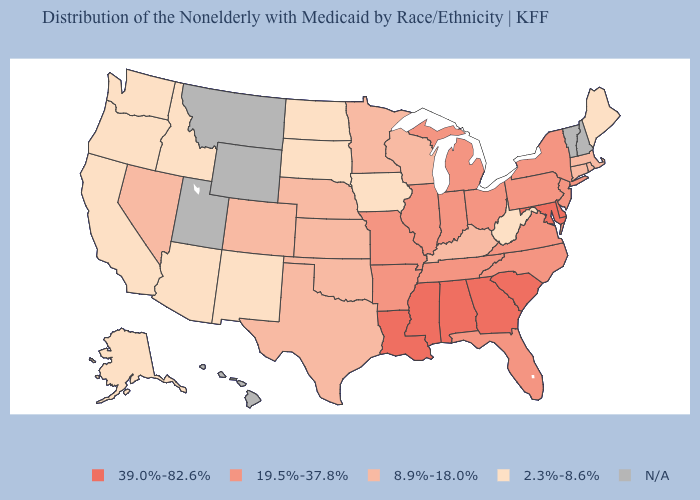Among the states that border New Mexico , which have the highest value?
Write a very short answer. Colorado, Oklahoma, Texas. Name the states that have a value in the range 2.3%-8.6%?
Keep it brief. Alaska, Arizona, California, Idaho, Iowa, Maine, New Mexico, North Dakota, Oregon, South Dakota, Washington, West Virginia. Does the first symbol in the legend represent the smallest category?
Give a very brief answer. No. What is the value of Pennsylvania?
Be succinct. 19.5%-37.8%. Among the states that border Louisiana , does Mississippi have the lowest value?
Be succinct. No. Name the states that have a value in the range 19.5%-37.8%?
Keep it brief. Arkansas, Florida, Illinois, Indiana, Michigan, Missouri, New Jersey, New York, North Carolina, Ohio, Pennsylvania, Tennessee, Virginia. Name the states that have a value in the range 39.0%-82.6%?
Give a very brief answer. Alabama, Delaware, Georgia, Louisiana, Maryland, Mississippi, South Carolina. What is the value of New York?
Concise answer only. 19.5%-37.8%. Name the states that have a value in the range N/A?
Answer briefly. Hawaii, Montana, New Hampshire, Utah, Vermont, Wyoming. Which states have the highest value in the USA?
Short answer required. Alabama, Delaware, Georgia, Louisiana, Maryland, Mississippi, South Carolina. What is the highest value in the MidWest ?
Concise answer only. 19.5%-37.8%. Name the states that have a value in the range 8.9%-18.0%?
Concise answer only. Colorado, Connecticut, Kansas, Kentucky, Massachusetts, Minnesota, Nebraska, Nevada, Oklahoma, Rhode Island, Texas, Wisconsin. 